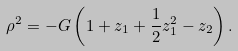<formula> <loc_0><loc_0><loc_500><loc_500>\rho ^ { 2 } = - G \left ( 1 + z _ { 1 } + \frac { 1 } { 2 } z _ { 1 } ^ { 2 } - z _ { 2 } \right ) .</formula> 